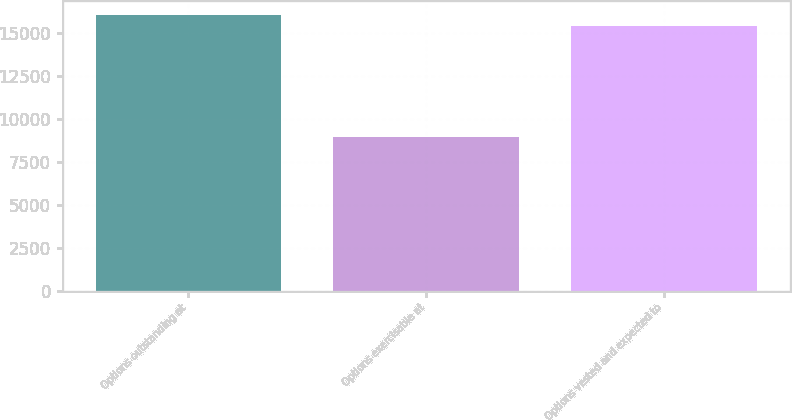<chart> <loc_0><loc_0><loc_500><loc_500><bar_chart><fcel>Options outstanding at<fcel>Options exercisable at<fcel>Options vested and expected to<nl><fcel>16063.4<fcel>8964<fcel>15412<nl></chart> 